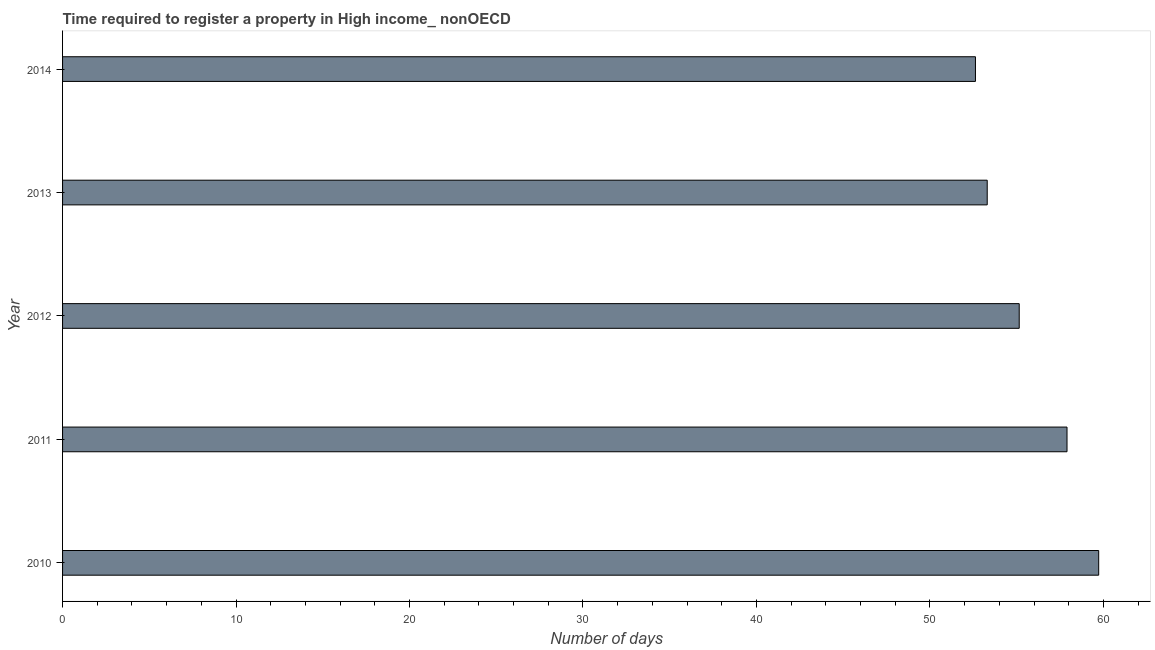Does the graph contain any zero values?
Your response must be concise. No. What is the title of the graph?
Your response must be concise. Time required to register a property in High income_ nonOECD. What is the label or title of the X-axis?
Offer a terse response. Number of days. What is the number of days required to register property in 2013?
Keep it short and to the point. 53.3. Across all years, what is the maximum number of days required to register property?
Make the answer very short. 59.73. Across all years, what is the minimum number of days required to register property?
Offer a terse response. 52.62. In which year was the number of days required to register property maximum?
Provide a short and direct response. 2010. In which year was the number of days required to register property minimum?
Provide a short and direct response. 2014. What is the sum of the number of days required to register property?
Make the answer very short. 278.71. What is the difference between the number of days required to register property in 2011 and 2014?
Offer a very short reply. 5.28. What is the average number of days required to register property per year?
Provide a short and direct response. 55.74. What is the median number of days required to register property?
Your response must be concise. 55.15. Is the difference between the number of days required to register property in 2011 and 2013 greater than the difference between any two years?
Provide a short and direct response. No. What is the difference between the highest and the second highest number of days required to register property?
Your response must be concise. 1.82. Is the sum of the number of days required to register property in 2011 and 2013 greater than the maximum number of days required to register property across all years?
Your answer should be compact. Yes. What is the difference between the highest and the lowest number of days required to register property?
Give a very brief answer. 7.1. In how many years, is the number of days required to register property greater than the average number of days required to register property taken over all years?
Provide a succinct answer. 2. What is the Number of days of 2010?
Make the answer very short. 59.73. What is the Number of days of 2011?
Give a very brief answer. 57.9. What is the Number of days of 2012?
Ensure brevity in your answer.  55.15. What is the Number of days in 2013?
Provide a succinct answer. 53.3. What is the Number of days in 2014?
Your response must be concise. 52.62. What is the difference between the Number of days in 2010 and 2011?
Provide a succinct answer. 1.83. What is the difference between the Number of days in 2010 and 2012?
Provide a succinct answer. 4.58. What is the difference between the Number of days in 2010 and 2013?
Offer a terse response. 6.43. What is the difference between the Number of days in 2010 and 2014?
Your answer should be compact. 7.1. What is the difference between the Number of days in 2011 and 2012?
Ensure brevity in your answer.  2.76. What is the difference between the Number of days in 2011 and 2013?
Make the answer very short. 4.6. What is the difference between the Number of days in 2011 and 2014?
Keep it short and to the point. 5.28. What is the difference between the Number of days in 2012 and 2013?
Give a very brief answer. 1.84. What is the difference between the Number of days in 2012 and 2014?
Make the answer very short. 2.52. What is the difference between the Number of days in 2013 and 2014?
Provide a succinct answer. 0.68. What is the ratio of the Number of days in 2010 to that in 2011?
Your answer should be very brief. 1.03. What is the ratio of the Number of days in 2010 to that in 2012?
Your response must be concise. 1.08. What is the ratio of the Number of days in 2010 to that in 2013?
Offer a very short reply. 1.12. What is the ratio of the Number of days in 2010 to that in 2014?
Your response must be concise. 1.14. What is the ratio of the Number of days in 2011 to that in 2012?
Offer a very short reply. 1.05. What is the ratio of the Number of days in 2011 to that in 2013?
Offer a very short reply. 1.09. What is the ratio of the Number of days in 2012 to that in 2013?
Ensure brevity in your answer.  1.03. What is the ratio of the Number of days in 2012 to that in 2014?
Offer a very short reply. 1.05. What is the ratio of the Number of days in 2013 to that in 2014?
Provide a short and direct response. 1.01. 